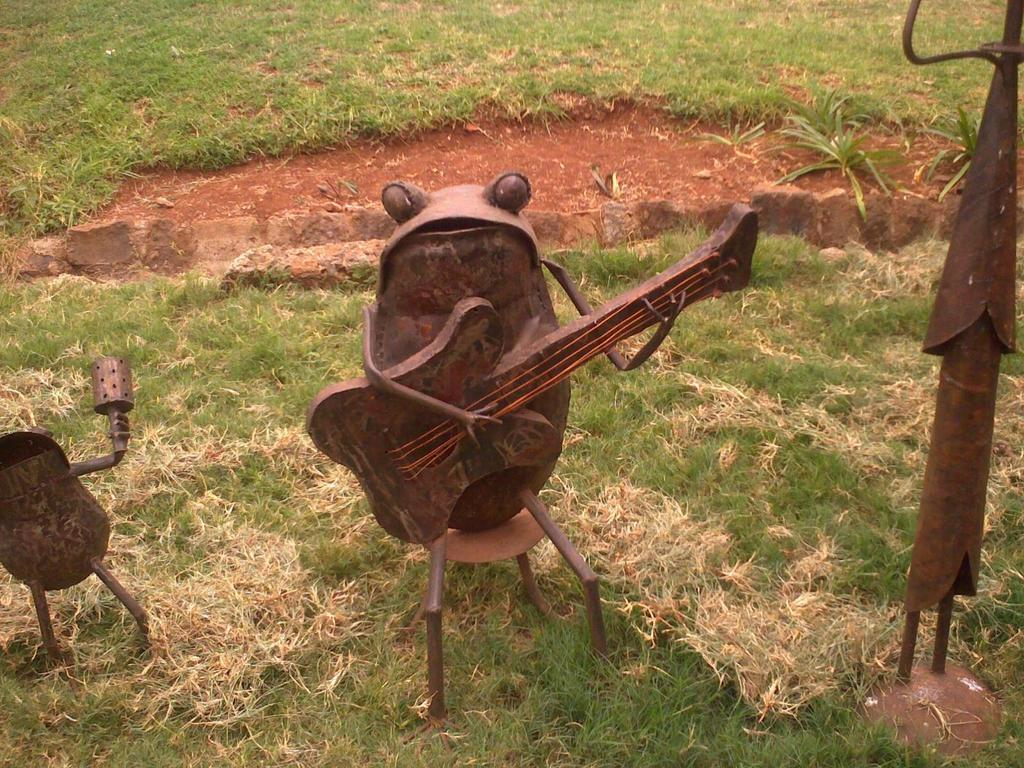What type of terrain is shown in the image? The image depicts a grassy land. What kind of objects can be seen on the grassy land? There are metallic crafts in the image. What type of food is being prepared on the grassy land in the image? There is no food preparation visible in the image; it only shows metallic crafts on a grassy land. 